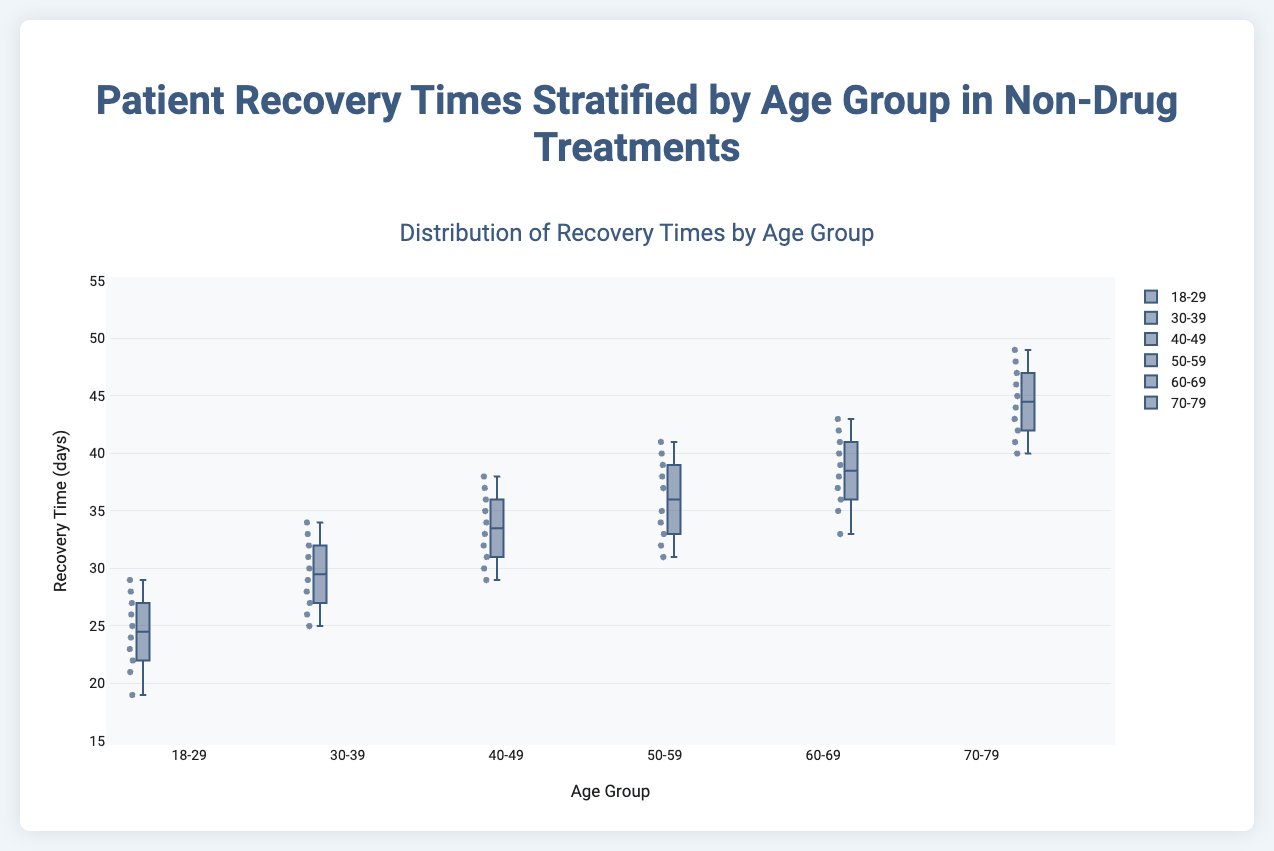What's the title of the plot? The title is displayed at the top of the chart. It reads "Distribution of Recovery Times by Age Group".
Answer: Distribution of Recovery Times by Age Group What does the y-axis represent? The y-axis is labeled "Recovery Time (days)" which represents the duration in days of patient recovery times.
Answer: Recovery Time (days) Which age group has the widest interquartile range (IQR)? The interquartile range (IQR) is the difference between the third quartile (Q3) and the first quartile (Q1). From the plot, the 70-79 age group shows the widest IQR.
Answer: 70-79 Do any of the age groups have outliers, and if so, which ones? Outliers are points outside the whiskers of the box plot. The plot indicates that the 18-29 age group has outliers displayed as separate points.
Answer: 18-29 Which age group has the highest median recovery time? The median is the line inside the box. The 70-79 age group has the highest median recovery time.
Answer: 70-79 How do the average recovery times compare between the 30-39 and 50-59 age groups? To compare averages, approximate the center value of the box (median) and add/subtract half the IQR to estimate the mean. The 50-59 age group generally shows a higher recovery time.
Answer: 50-59 higher What's the range of recovery times for the 60-69 age group? The range can be determined from the lowest to the highest value within the whiskers. For the 60-69 age group, it extends from approximately 33 to 43 days.
Answer: 33 to 43 days Which age group shows the smallest variability in recovery times? Variability is indicated by the distance between the whiskers. The 18-29 age group has the narrowest distance hence the smallest variability.
Answer: 18-29 Among all age groups, which one has the lowest minimum recovery time? The minimum recovery time is the lowest end of the whisker. The 18-29 age group has the lowest minimum recovery time.
Answer: 18-29 